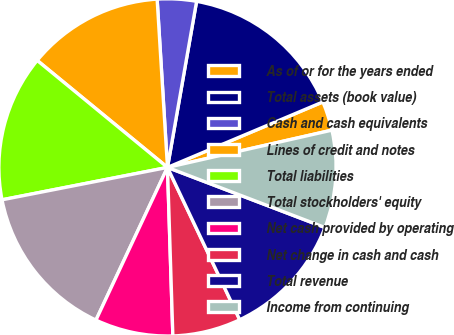Convert chart. <chart><loc_0><loc_0><loc_500><loc_500><pie_chart><fcel>As of or for the years ended<fcel>Total assets (book value)<fcel>Cash and cash equivalents<fcel>Lines of credit and notes<fcel>Total liabilities<fcel>Total stockholders' equity<fcel>Net cash provided by operating<fcel>Net change in cash and cash<fcel>Total revenue<fcel>Income from continuing<nl><fcel>2.8%<fcel>15.89%<fcel>3.74%<fcel>13.08%<fcel>14.02%<fcel>14.95%<fcel>7.48%<fcel>6.54%<fcel>12.15%<fcel>9.35%<nl></chart> 